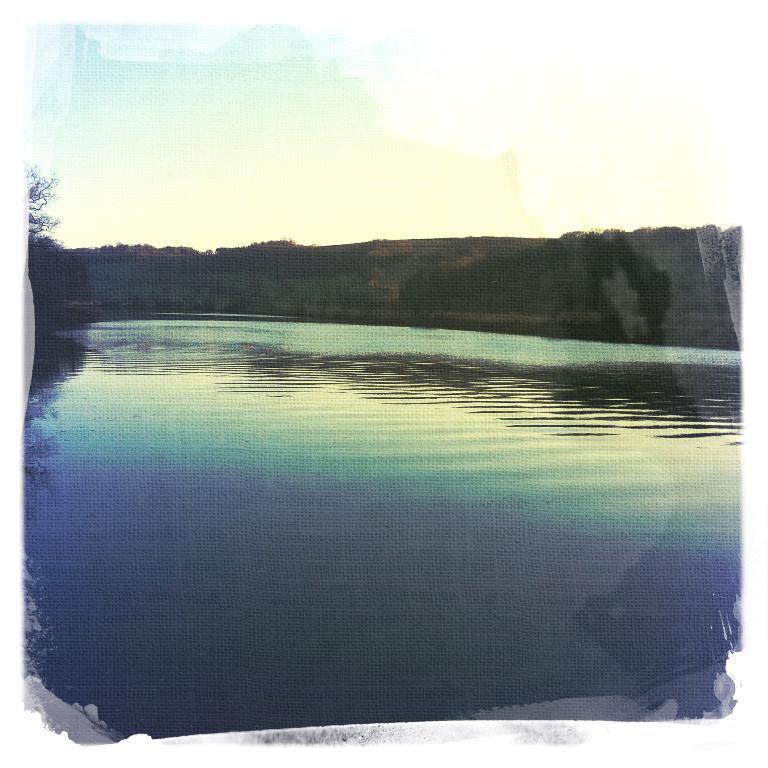Describe this image in one or two sentences. In this image there is a lake and we can see trees. In the background there is a rock and sky. 